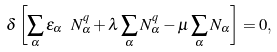Convert formula to latex. <formula><loc_0><loc_0><loc_500><loc_500>\delta \left [ \sum _ { \alpha } \varepsilon _ { \alpha } \ N _ { \alpha } ^ { q } + \lambda \sum _ { \alpha } N _ { \alpha } ^ { q } - \mu \sum _ { \alpha } N _ { \alpha } \right ] = 0 ,</formula> 